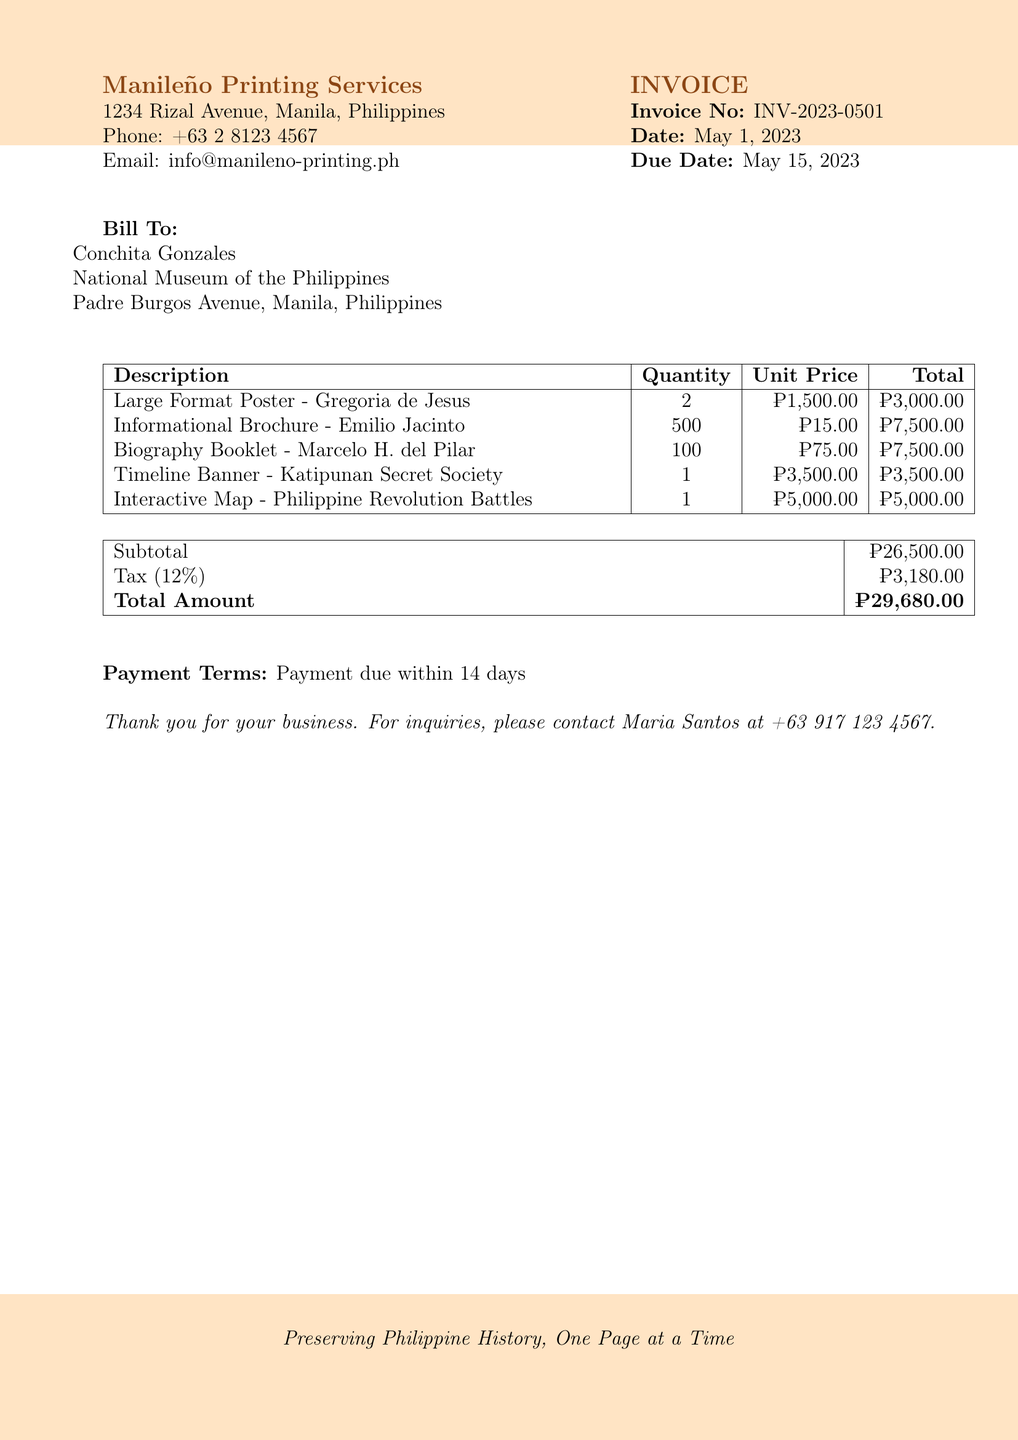What is the invoice number? The invoice number is listed at the top of the document under "Invoice", explicitly stated as INV-2023-0501.
Answer: INV-2023-0501 What is the total amount due? The total amount due is provided in the document, highlighting the final figure at the bottom of the billing section, which sums up the subtotal and tax.
Answer: ₱29,680.00 Who is the bill addressed to? The bill is addressed to Conchita Gonzales, indicated under the "Bill To:" section of the document.
Answer: Conchita Gonzales What is the quantity of the Informational Brochure? The quantity for the Informational Brochure is specified in the table of billed items under the "Quantity" column.
Answer: 500 What is the subtotal amount? The subtotal amount is clearly stated in the table before the tax is added, summarizing the costs for the printing services.
Answer: ₱26,500.00 What service has the highest unit price? To determine the service with the highest unit price, we can compare all listed unit prices in the table, with the Interactive Map being the highest at ₱5,000.00.
Answer: ₱5,000.00 When is the payment due? The payment due date is indicated in the document, following the "Due Date" information listed next to the invoice date.
Answer: May 15, 2023 How much tax is applied? The tax amount is specifically calculated as a percentage of the subtotal and listed in the table that summarizes the billing details.
Answer: ₱3,180.00 